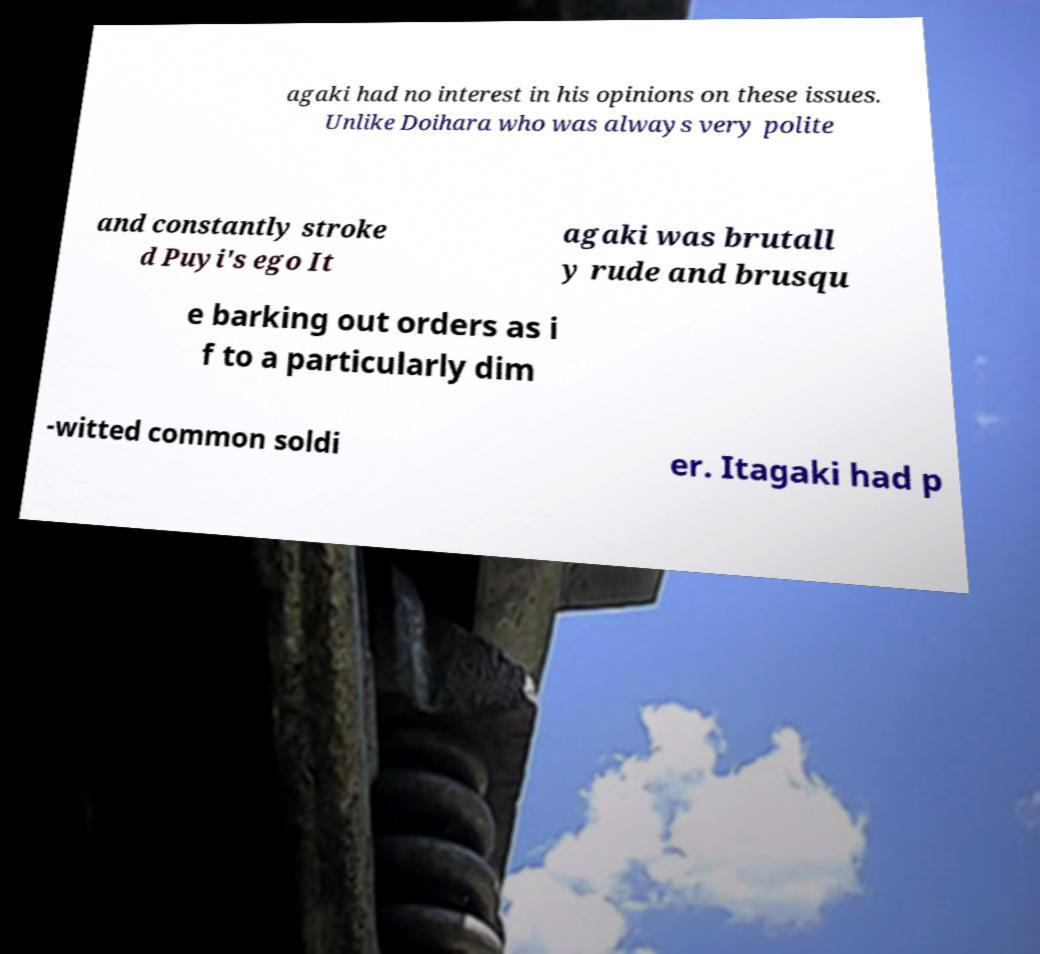Could you assist in decoding the text presented in this image and type it out clearly? agaki had no interest in his opinions on these issues. Unlike Doihara who was always very polite and constantly stroke d Puyi's ego It agaki was brutall y rude and brusqu e barking out orders as i f to a particularly dim -witted common soldi er. Itagaki had p 